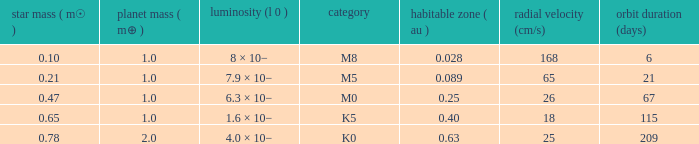What is the smallest period (days) to have a planetary mass of 1, a stellar mass greater than 0.21 and of the type M0? 67.0. 